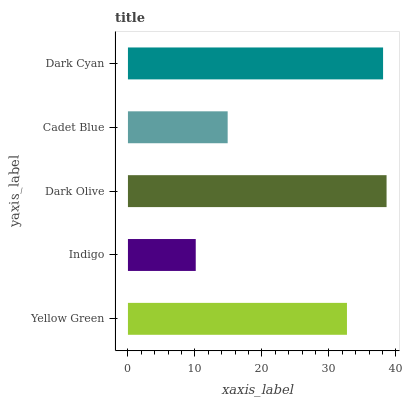Is Indigo the minimum?
Answer yes or no. Yes. Is Dark Olive the maximum?
Answer yes or no. Yes. Is Dark Olive the minimum?
Answer yes or no. No. Is Indigo the maximum?
Answer yes or no. No. Is Dark Olive greater than Indigo?
Answer yes or no. Yes. Is Indigo less than Dark Olive?
Answer yes or no. Yes. Is Indigo greater than Dark Olive?
Answer yes or no. No. Is Dark Olive less than Indigo?
Answer yes or no. No. Is Yellow Green the high median?
Answer yes or no. Yes. Is Yellow Green the low median?
Answer yes or no. Yes. Is Dark Cyan the high median?
Answer yes or no. No. Is Dark Olive the low median?
Answer yes or no. No. 